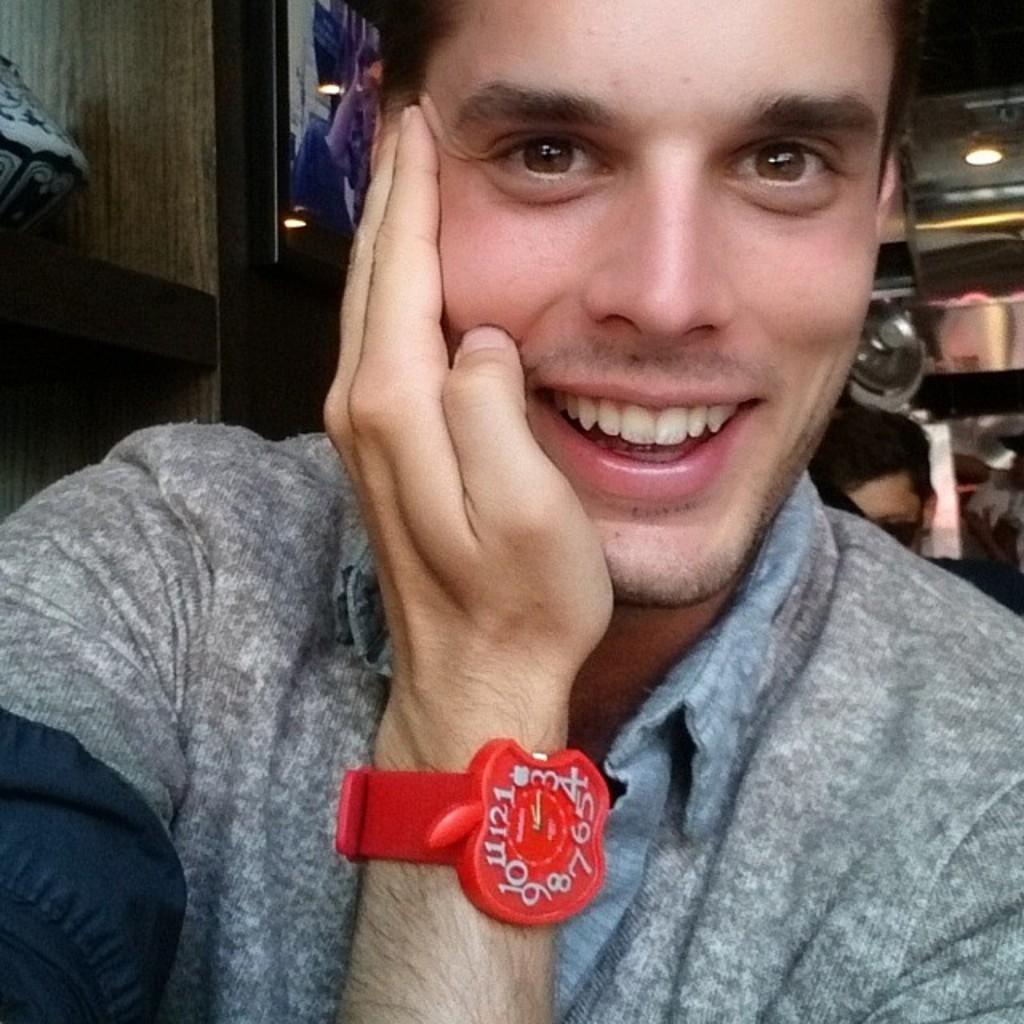Who or what is present in the image? There is a person in the image. What can be observed about the person's attire? The person is wearing clothes. Are there any accessories visible on the person? Yes, the person is wearing a watch. Where is the person's head located in the image? The person's head is on the right side of the image. What can be seen in the top right corner of the image? There is a light in the top right of the image. How does the snake move along the rail in the image? There is no snake or rail present in the image; it only features a person with a watch. 